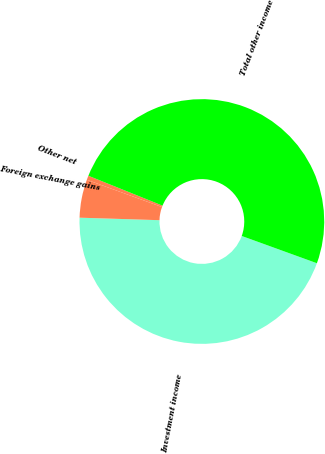<chart> <loc_0><loc_0><loc_500><loc_500><pie_chart><fcel>Investment income<fcel>Foreign exchange gains<fcel>Other net<fcel>Total other income<nl><fcel>44.96%<fcel>5.04%<fcel>0.56%<fcel>49.44%<nl></chart> 